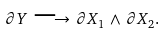<formula> <loc_0><loc_0><loc_500><loc_500>\partial Y \, \longrightarrow \, \partial X _ { 1 } \, \wedge \, \partial X _ { 2 } .</formula> 